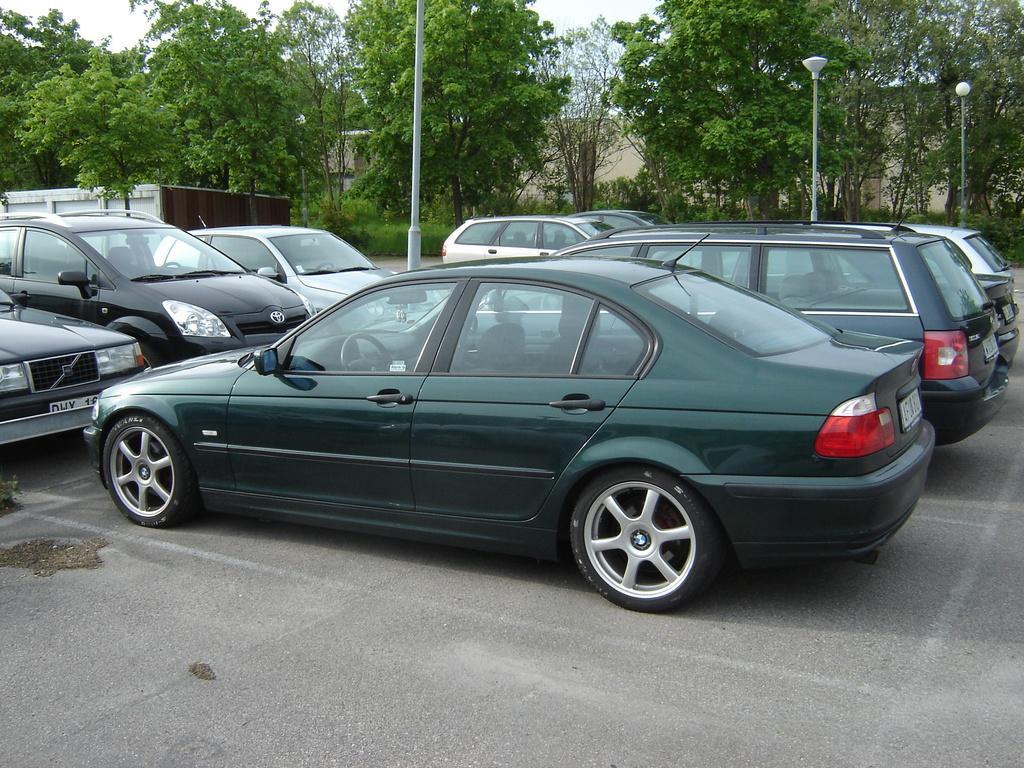In one or two sentences, can you explain what this image depicts? The picture is taken in a parking lot. In this picture there are cars, poles and road. In the background there are trees and building. 